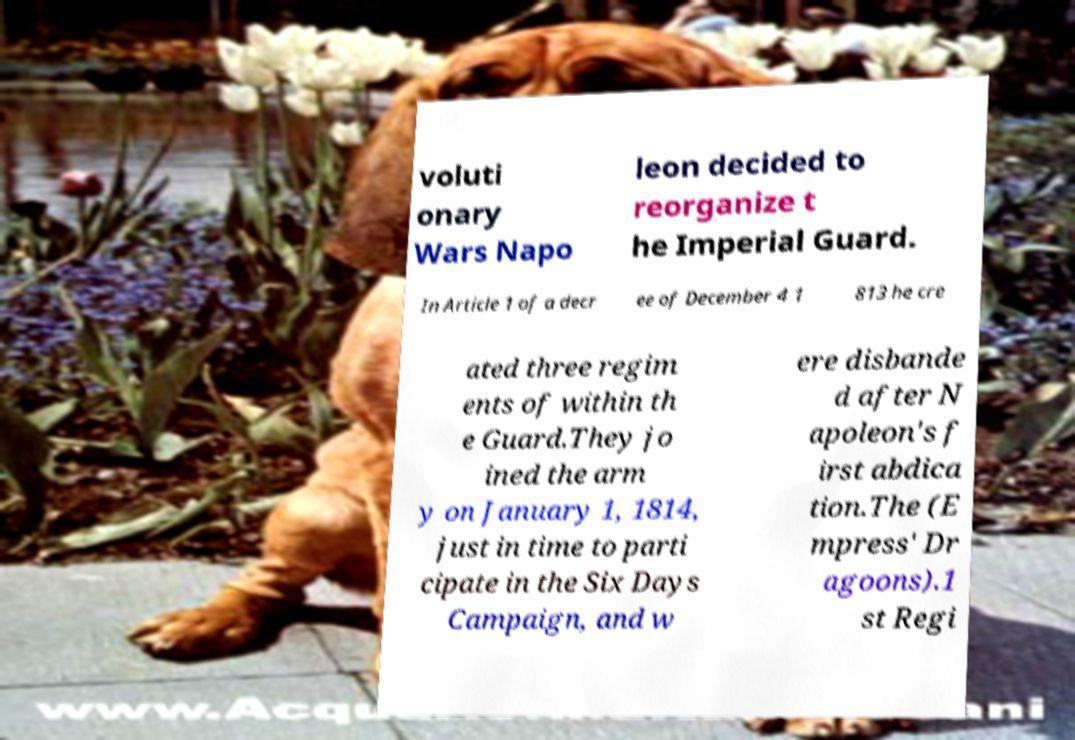Please identify and transcribe the text found in this image. voluti onary Wars Napo leon decided to reorganize t he Imperial Guard. In Article 1 of a decr ee of December 4 1 813 he cre ated three regim ents of within th e Guard.They jo ined the arm y on January 1, 1814, just in time to parti cipate in the Six Days Campaign, and w ere disbande d after N apoleon's f irst abdica tion.The (E mpress' Dr agoons).1 st Regi 